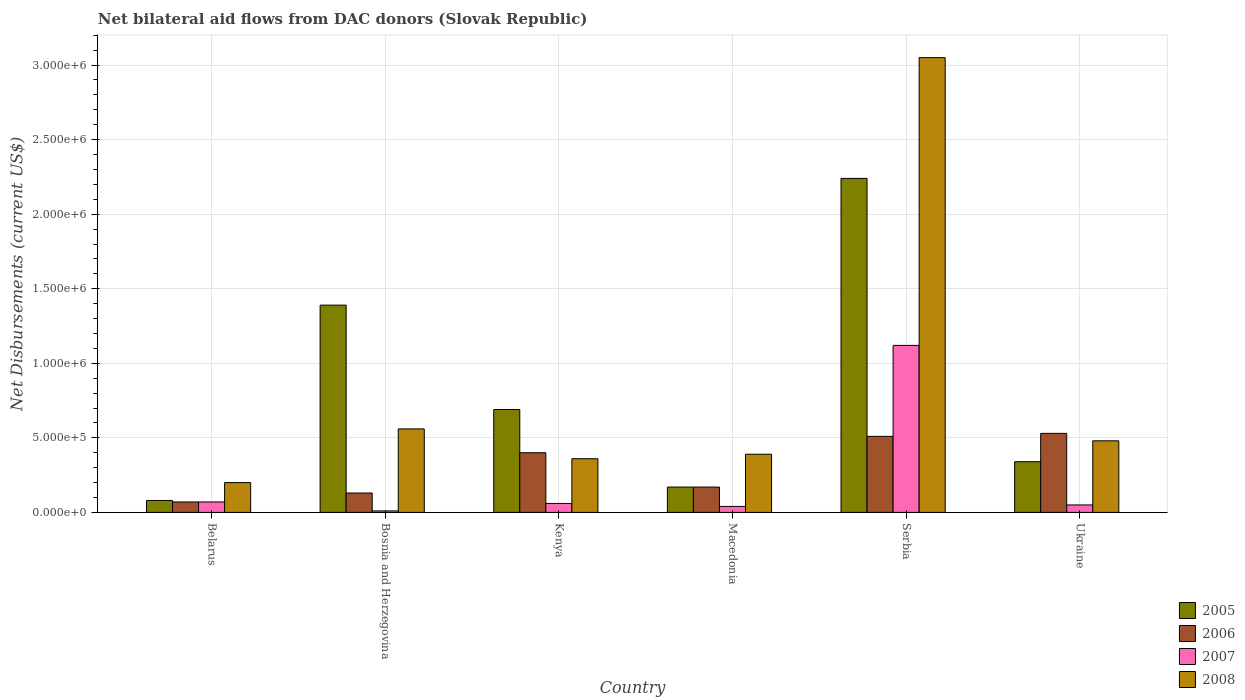How many groups of bars are there?
Make the answer very short. 6. Are the number of bars per tick equal to the number of legend labels?
Provide a succinct answer. Yes. Are the number of bars on each tick of the X-axis equal?
Offer a terse response. Yes. How many bars are there on the 1st tick from the right?
Offer a terse response. 4. What is the label of the 3rd group of bars from the left?
Your answer should be very brief. Kenya. Across all countries, what is the maximum net bilateral aid flows in 2008?
Keep it short and to the point. 3.05e+06. In which country was the net bilateral aid flows in 2006 maximum?
Keep it short and to the point. Ukraine. In which country was the net bilateral aid flows in 2006 minimum?
Make the answer very short. Belarus. What is the total net bilateral aid flows in 2007 in the graph?
Provide a short and direct response. 1.35e+06. What is the difference between the net bilateral aid flows in 2008 in Serbia and that in Ukraine?
Keep it short and to the point. 2.57e+06. What is the difference between the net bilateral aid flows in 2007 in Kenya and the net bilateral aid flows in 2008 in Bosnia and Herzegovina?
Make the answer very short. -5.00e+05. What is the average net bilateral aid flows in 2005 per country?
Keep it short and to the point. 8.18e+05. What is the difference between the net bilateral aid flows of/in 2006 and net bilateral aid flows of/in 2005 in Serbia?
Your answer should be very brief. -1.73e+06. In how many countries, is the net bilateral aid flows in 2006 greater than 300000 US$?
Your answer should be compact. 3. What is the ratio of the net bilateral aid flows in 2006 in Belarus to that in Bosnia and Herzegovina?
Your answer should be very brief. 0.54. Is the difference between the net bilateral aid flows in 2006 in Belarus and Macedonia greater than the difference between the net bilateral aid flows in 2005 in Belarus and Macedonia?
Provide a succinct answer. No. What is the difference between the highest and the second highest net bilateral aid flows in 2007?
Provide a short and direct response. 1.05e+06. What is the difference between the highest and the lowest net bilateral aid flows in 2006?
Give a very brief answer. 4.60e+05. Is the sum of the net bilateral aid flows in 2007 in Macedonia and Ukraine greater than the maximum net bilateral aid flows in 2008 across all countries?
Ensure brevity in your answer.  No. Is it the case that in every country, the sum of the net bilateral aid flows in 2006 and net bilateral aid flows in 2008 is greater than the sum of net bilateral aid flows in 2005 and net bilateral aid flows in 2007?
Give a very brief answer. Yes. How many countries are there in the graph?
Give a very brief answer. 6. What is the difference between two consecutive major ticks on the Y-axis?
Provide a short and direct response. 5.00e+05. Are the values on the major ticks of Y-axis written in scientific E-notation?
Give a very brief answer. Yes. Does the graph contain any zero values?
Give a very brief answer. No. Does the graph contain grids?
Ensure brevity in your answer.  Yes. Where does the legend appear in the graph?
Make the answer very short. Bottom right. How many legend labels are there?
Offer a terse response. 4. What is the title of the graph?
Keep it short and to the point. Net bilateral aid flows from DAC donors (Slovak Republic). Does "1979" appear as one of the legend labels in the graph?
Provide a succinct answer. No. What is the label or title of the X-axis?
Your response must be concise. Country. What is the label or title of the Y-axis?
Offer a very short reply. Net Disbursements (current US$). What is the Net Disbursements (current US$) in 2005 in Belarus?
Provide a short and direct response. 8.00e+04. What is the Net Disbursements (current US$) of 2006 in Belarus?
Your answer should be very brief. 7.00e+04. What is the Net Disbursements (current US$) of 2007 in Belarus?
Offer a terse response. 7.00e+04. What is the Net Disbursements (current US$) in 2005 in Bosnia and Herzegovina?
Make the answer very short. 1.39e+06. What is the Net Disbursements (current US$) of 2006 in Bosnia and Herzegovina?
Offer a terse response. 1.30e+05. What is the Net Disbursements (current US$) of 2008 in Bosnia and Herzegovina?
Provide a succinct answer. 5.60e+05. What is the Net Disbursements (current US$) of 2005 in Kenya?
Your answer should be very brief. 6.90e+05. What is the Net Disbursements (current US$) of 2007 in Kenya?
Offer a terse response. 6.00e+04. What is the Net Disbursements (current US$) in 2008 in Kenya?
Keep it short and to the point. 3.60e+05. What is the Net Disbursements (current US$) of 2005 in Macedonia?
Offer a terse response. 1.70e+05. What is the Net Disbursements (current US$) of 2007 in Macedonia?
Your answer should be compact. 4.00e+04. What is the Net Disbursements (current US$) in 2008 in Macedonia?
Give a very brief answer. 3.90e+05. What is the Net Disbursements (current US$) in 2005 in Serbia?
Ensure brevity in your answer.  2.24e+06. What is the Net Disbursements (current US$) of 2006 in Serbia?
Your response must be concise. 5.10e+05. What is the Net Disbursements (current US$) of 2007 in Serbia?
Your answer should be very brief. 1.12e+06. What is the Net Disbursements (current US$) in 2008 in Serbia?
Your answer should be very brief. 3.05e+06. What is the Net Disbursements (current US$) of 2005 in Ukraine?
Keep it short and to the point. 3.40e+05. What is the Net Disbursements (current US$) of 2006 in Ukraine?
Offer a very short reply. 5.30e+05. What is the Net Disbursements (current US$) in 2008 in Ukraine?
Make the answer very short. 4.80e+05. Across all countries, what is the maximum Net Disbursements (current US$) of 2005?
Keep it short and to the point. 2.24e+06. Across all countries, what is the maximum Net Disbursements (current US$) in 2006?
Offer a very short reply. 5.30e+05. Across all countries, what is the maximum Net Disbursements (current US$) in 2007?
Provide a short and direct response. 1.12e+06. Across all countries, what is the maximum Net Disbursements (current US$) of 2008?
Give a very brief answer. 3.05e+06. Across all countries, what is the minimum Net Disbursements (current US$) in 2007?
Give a very brief answer. 10000. Across all countries, what is the minimum Net Disbursements (current US$) in 2008?
Give a very brief answer. 2.00e+05. What is the total Net Disbursements (current US$) of 2005 in the graph?
Your response must be concise. 4.91e+06. What is the total Net Disbursements (current US$) in 2006 in the graph?
Offer a very short reply. 1.81e+06. What is the total Net Disbursements (current US$) of 2007 in the graph?
Make the answer very short. 1.35e+06. What is the total Net Disbursements (current US$) in 2008 in the graph?
Offer a very short reply. 5.04e+06. What is the difference between the Net Disbursements (current US$) of 2005 in Belarus and that in Bosnia and Herzegovina?
Give a very brief answer. -1.31e+06. What is the difference between the Net Disbursements (current US$) in 2006 in Belarus and that in Bosnia and Herzegovina?
Your answer should be compact. -6.00e+04. What is the difference between the Net Disbursements (current US$) in 2008 in Belarus and that in Bosnia and Herzegovina?
Make the answer very short. -3.60e+05. What is the difference between the Net Disbursements (current US$) of 2005 in Belarus and that in Kenya?
Ensure brevity in your answer.  -6.10e+05. What is the difference between the Net Disbursements (current US$) in 2006 in Belarus and that in Kenya?
Offer a very short reply. -3.30e+05. What is the difference between the Net Disbursements (current US$) in 2005 in Belarus and that in Macedonia?
Provide a short and direct response. -9.00e+04. What is the difference between the Net Disbursements (current US$) in 2008 in Belarus and that in Macedonia?
Your answer should be very brief. -1.90e+05. What is the difference between the Net Disbursements (current US$) in 2005 in Belarus and that in Serbia?
Offer a very short reply. -2.16e+06. What is the difference between the Net Disbursements (current US$) of 2006 in Belarus and that in Serbia?
Give a very brief answer. -4.40e+05. What is the difference between the Net Disbursements (current US$) of 2007 in Belarus and that in Serbia?
Your response must be concise. -1.05e+06. What is the difference between the Net Disbursements (current US$) of 2008 in Belarus and that in Serbia?
Provide a short and direct response. -2.85e+06. What is the difference between the Net Disbursements (current US$) in 2006 in Belarus and that in Ukraine?
Ensure brevity in your answer.  -4.60e+05. What is the difference between the Net Disbursements (current US$) of 2007 in Belarus and that in Ukraine?
Provide a succinct answer. 2.00e+04. What is the difference between the Net Disbursements (current US$) in 2008 in Belarus and that in Ukraine?
Provide a succinct answer. -2.80e+05. What is the difference between the Net Disbursements (current US$) of 2006 in Bosnia and Herzegovina and that in Kenya?
Offer a terse response. -2.70e+05. What is the difference between the Net Disbursements (current US$) of 2008 in Bosnia and Herzegovina and that in Kenya?
Your answer should be very brief. 2.00e+05. What is the difference between the Net Disbursements (current US$) in 2005 in Bosnia and Herzegovina and that in Macedonia?
Give a very brief answer. 1.22e+06. What is the difference between the Net Disbursements (current US$) of 2006 in Bosnia and Herzegovina and that in Macedonia?
Provide a succinct answer. -4.00e+04. What is the difference between the Net Disbursements (current US$) in 2008 in Bosnia and Herzegovina and that in Macedonia?
Keep it short and to the point. 1.70e+05. What is the difference between the Net Disbursements (current US$) in 2005 in Bosnia and Herzegovina and that in Serbia?
Your answer should be very brief. -8.50e+05. What is the difference between the Net Disbursements (current US$) in 2006 in Bosnia and Herzegovina and that in Serbia?
Offer a terse response. -3.80e+05. What is the difference between the Net Disbursements (current US$) in 2007 in Bosnia and Herzegovina and that in Serbia?
Offer a terse response. -1.11e+06. What is the difference between the Net Disbursements (current US$) of 2008 in Bosnia and Herzegovina and that in Serbia?
Your answer should be compact. -2.49e+06. What is the difference between the Net Disbursements (current US$) in 2005 in Bosnia and Herzegovina and that in Ukraine?
Your answer should be very brief. 1.05e+06. What is the difference between the Net Disbursements (current US$) of 2006 in Bosnia and Herzegovina and that in Ukraine?
Your response must be concise. -4.00e+05. What is the difference between the Net Disbursements (current US$) of 2008 in Bosnia and Herzegovina and that in Ukraine?
Your response must be concise. 8.00e+04. What is the difference between the Net Disbursements (current US$) in 2005 in Kenya and that in Macedonia?
Your response must be concise. 5.20e+05. What is the difference between the Net Disbursements (current US$) in 2007 in Kenya and that in Macedonia?
Ensure brevity in your answer.  2.00e+04. What is the difference between the Net Disbursements (current US$) of 2005 in Kenya and that in Serbia?
Make the answer very short. -1.55e+06. What is the difference between the Net Disbursements (current US$) in 2006 in Kenya and that in Serbia?
Your response must be concise. -1.10e+05. What is the difference between the Net Disbursements (current US$) in 2007 in Kenya and that in Serbia?
Keep it short and to the point. -1.06e+06. What is the difference between the Net Disbursements (current US$) of 2008 in Kenya and that in Serbia?
Keep it short and to the point. -2.69e+06. What is the difference between the Net Disbursements (current US$) of 2006 in Kenya and that in Ukraine?
Offer a terse response. -1.30e+05. What is the difference between the Net Disbursements (current US$) of 2007 in Kenya and that in Ukraine?
Offer a terse response. 10000. What is the difference between the Net Disbursements (current US$) in 2008 in Kenya and that in Ukraine?
Ensure brevity in your answer.  -1.20e+05. What is the difference between the Net Disbursements (current US$) of 2005 in Macedonia and that in Serbia?
Offer a very short reply. -2.07e+06. What is the difference between the Net Disbursements (current US$) of 2007 in Macedonia and that in Serbia?
Make the answer very short. -1.08e+06. What is the difference between the Net Disbursements (current US$) in 2008 in Macedonia and that in Serbia?
Provide a succinct answer. -2.66e+06. What is the difference between the Net Disbursements (current US$) of 2005 in Macedonia and that in Ukraine?
Ensure brevity in your answer.  -1.70e+05. What is the difference between the Net Disbursements (current US$) of 2006 in Macedonia and that in Ukraine?
Offer a very short reply. -3.60e+05. What is the difference between the Net Disbursements (current US$) in 2007 in Macedonia and that in Ukraine?
Offer a very short reply. -10000. What is the difference between the Net Disbursements (current US$) of 2005 in Serbia and that in Ukraine?
Your response must be concise. 1.90e+06. What is the difference between the Net Disbursements (current US$) in 2006 in Serbia and that in Ukraine?
Your answer should be compact. -2.00e+04. What is the difference between the Net Disbursements (current US$) in 2007 in Serbia and that in Ukraine?
Your response must be concise. 1.07e+06. What is the difference between the Net Disbursements (current US$) in 2008 in Serbia and that in Ukraine?
Make the answer very short. 2.57e+06. What is the difference between the Net Disbursements (current US$) in 2005 in Belarus and the Net Disbursements (current US$) in 2006 in Bosnia and Herzegovina?
Your answer should be very brief. -5.00e+04. What is the difference between the Net Disbursements (current US$) in 2005 in Belarus and the Net Disbursements (current US$) in 2007 in Bosnia and Herzegovina?
Your response must be concise. 7.00e+04. What is the difference between the Net Disbursements (current US$) of 2005 in Belarus and the Net Disbursements (current US$) of 2008 in Bosnia and Herzegovina?
Ensure brevity in your answer.  -4.80e+05. What is the difference between the Net Disbursements (current US$) in 2006 in Belarus and the Net Disbursements (current US$) in 2007 in Bosnia and Herzegovina?
Keep it short and to the point. 6.00e+04. What is the difference between the Net Disbursements (current US$) of 2006 in Belarus and the Net Disbursements (current US$) of 2008 in Bosnia and Herzegovina?
Your answer should be very brief. -4.90e+05. What is the difference between the Net Disbursements (current US$) of 2007 in Belarus and the Net Disbursements (current US$) of 2008 in Bosnia and Herzegovina?
Provide a succinct answer. -4.90e+05. What is the difference between the Net Disbursements (current US$) of 2005 in Belarus and the Net Disbursements (current US$) of 2006 in Kenya?
Give a very brief answer. -3.20e+05. What is the difference between the Net Disbursements (current US$) of 2005 in Belarus and the Net Disbursements (current US$) of 2008 in Kenya?
Ensure brevity in your answer.  -2.80e+05. What is the difference between the Net Disbursements (current US$) of 2006 in Belarus and the Net Disbursements (current US$) of 2008 in Kenya?
Provide a succinct answer. -2.90e+05. What is the difference between the Net Disbursements (current US$) in 2005 in Belarus and the Net Disbursements (current US$) in 2006 in Macedonia?
Keep it short and to the point. -9.00e+04. What is the difference between the Net Disbursements (current US$) in 2005 in Belarus and the Net Disbursements (current US$) in 2007 in Macedonia?
Make the answer very short. 4.00e+04. What is the difference between the Net Disbursements (current US$) in 2005 in Belarus and the Net Disbursements (current US$) in 2008 in Macedonia?
Your answer should be very brief. -3.10e+05. What is the difference between the Net Disbursements (current US$) of 2006 in Belarus and the Net Disbursements (current US$) of 2008 in Macedonia?
Keep it short and to the point. -3.20e+05. What is the difference between the Net Disbursements (current US$) of 2007 in Belarus and the Net Disbursements (current US$) of 2008 in Macedonia?
Provide a succinct answer. -3.20e+05. What is the difference between the Net Disbursements (current US$) of 2005 in Belarus and the Net Disbursements (current US$) of 2006 in Serbia?
Provide a short and direct response. -4.30e+05. What is the difference between the Net Disbursements (current US$) in 2005 in Belarus and the Net Disbursements (current US$) in 2007 in Serbia?
Provide a short and direct response. -1.04e+06. What is the difference between the Net Disbursements (current US$) in 2005 in Belarus and the Net Disbursements (current US$) in 2008 in Serbia?
Keep it short and to the point. -2.97e+06. What is the difference between the Net Disbursements (current US$) in 2006 in Belarus and the Net Disbursements (current US$) in 2007 in Serbia?
Your answer should be compact. -1.05e+06. What is the difference between the Net Disbursements (current US$) of 2006 in Belarus and the Net Disbursements (current US$) of 2008 in Serbia?
Give a very brief answer. -2.98e+06. What is the difference between the Net Disbursements (current US$) in 2007 in Belarus and the Net Disbursements (current US$) in 2008 in Serbia?
Your answer should be very brief. -2.98e+06. What is the difference between the Net Disbursements (current US$) of 2005 in Belarus and the Net Disbursements (current US$) of 2006 in Ukraine?
Keep it short and to the point. -4.50e+05. What is the difference between the Net Disbursements (current US$) of 2005 in Belarus and the Net Disbursements (current US$) of 2007 in Ukraine?
Ensure brevity in your answer.  3.00e+04. What is the difference between the Net Disbursements (current US$) of 2005 in Belarus and the Net Disbursements (current US$) of 2008 in Ukraine?
Offer a very short reply. -4.00e+05. What is the difference between the Net Disbursements (current US$) of 2006 in Belarus and the Net Disbursements (current US$) of 2007 in Ukraine?
Offer a terse response. 2.00e+04. What is the difference between the Net Disbursements (current US$) in 2006 in Belarus and the Net Disbursements (current US$) in 2008 in Ukraine?
Your response must be concise. -4.10e+05. What is the difference between the Net Disbursements (current US$) in 2007 in Belarus and the Net Disbursements (current US$) in 2008 in Ukraine?
Your response must be concise. -4.10e+05. What is the difference between the Net Disbursements (current US$) in 2005 in Bosnia and Herzegovina and the Net Disbursements (current US$) in 2006 in Kenya?
Your response must be concise. 9.90e+05. What is the difference between the Net Disbursements (current US$) in 2005 in Bosnia and Herzegovina and the Net Disbursements (current US$) in 2007 in Kenya?
Your answer should be very brief. 1.33e+06. What is the difference between the Net Disbursements (current US$) of 2005 in Bosnia and Herzegovina and the Net Disbursements (current US$) of 2008 in Kenya?
Your response must be concise. 1.03e+06. What is the difference between the Net Disbursements (current US$) of 2006 in Bosnia and Herzegovina and the Net Disbursements (current US$) of 2008 in Kenya?
Your response must be concise. -2.30e+05. What is the difference between the Net Disbursements (current US$) in 2007 in Bosnia and Herzegovina and the Net Disbursements (current US$) in 2008 in Kenya?
Give a very brief answer. -3.50e+05. What is the difference between the Net Disbursements (current US$) in 2005 in Bosnia and Herzegovina and the Net Disbursements (current US$) in 2006 in Macedonia?
Your answer should be compact. 1.22e+06. What is the difference between the Net Disbursements (current US$) in 2005 in Bosnia and Herzegovina and the Net Disbursements (current US$) in 2007 in Macedonia?
Give a very brief answer. 1.35e+06. What is the difference between the Net Disbursements (current US$) in 2005 in Bosnia and Herzegovina and the Net Disbursements (current US$) in 2008 in Macedonia?
Your answer should be compact. 1.00e+06. What is the difference between the Net Disbursements (current US$) of 2006 in Bosnia and Herzegovina and the Net Disbursements (current US$) of 2007 in Macedonia?
Offer a terse response. 9.00e+04. What is the difference between the Net Disbursements (current US$) in 2007 in Bosnia and Herzegovina and the Net Disbursements (current US$) in 2008 in Macedonia?
Offer a terse response. -3.80e+05. What is the difference between the Net Disbursements (current US$) of 2005 in Bosnia and Herzegovina and the Net Disbursements (current US$) of 2006 in Serbia?
Your answer should be very brief. 8.80e+05. What is the difference between the Net Disbursements (current US$) in 2005 in Bosnia and Herzegovina and the Net Disbursements (current US$) in 2007 in Serbia?
Provide a short and direct response. 2.70e+05. What is the difference between the Net Disbursements (current US$) in 2005 in Bosnia and Herzegovina and the Net Disbursements (current US$) in 2008 in Serbia?
Your response must be concise. -1.66e+06. What is the difference between the Net Disbursements (current US$) in 2006 in Bosnia and Herzegovina and the Net Disbursements (current US$) in 2007 in Serbia?
Keep it short and to the point. -9.90e+05. What is the difference between the Net Disbursements (current US$) in 2006 in Bosnia and Herzegovina and the Net Disbursements (current US$) in 2008 in Serbia?
Offer a terse response. -2.92e+06. What is the difference between the Net Disbursements (current US$) of 2007 in Bosnia and Herzegovina and the Net Disbursements (current US$) of 2008 in Serbia?
Provide a succinct answer. -3.04e+06. What is the difference between the Net Disbursements (current US$) in 2005 in Bosnia and Herzegovina and the Net Disbursements (current US$) in 2006 in Ukraine?
Provide a short and direct response. 8.60e+05. What is the difference between the Net Disbursements (current US$) of 2005 in Bosnia and Herzegovina and the Net Disbursements (current US$) of 2007 in Ukraine?
Provide a short and direct response. 1.34e+06. What is the difference between the Net Disbursements (current US$) of 2005 in Bosnia and Herzegovina and the Net Disbursements (current US$) of 2008 in Ukraine?
Your answer should be compact. 9.10e+05. What is the difference between the Net Disbursements (current US$) in 2006 in Bosnia and Herzegovina and the Net Disbursements (current US$) in 2007 in Ukraine?
Your answer should be very brief. 8.00e+04. What is the difference between the Net Disbursements (current US$) of 2006 in Bosnia and Herzegovina and the Net Disbursements (current US$) of 2008 in Ukraine?
Your answer should be very brief. -3.50e+05. What is the difference between the Net Disbursements (current US$) in 2007 in Bosnia and Herzegovina and the Net Disbursements (current US$) in 2008 in Ukraine?
Ensure brevity in your answer.  -4.70e+05. What is the difference between the Net Disbursements (current US$) in 2005 in Kenya and the Net Disbursements (current US$) in 2006 in Macedonia?
Ensure brevity in your answer.  5.20e+05. What is the difference between the Net Disbursements (current US$) in 2005 in Kenya and the Net Disbursements (current US$) in 2007 in Macedonia?
Offer a terse response. 6.50e+05. What is the difference between the Net Disbursements (current US$) in 2005 in Kenya and the Net Disbursements (current US$) in 2008 in Macedonia?
Give a very brief answer. 3.00e+05. What is the difference between the Net Disbursements (current US$) in 2006 in Kenya and the Net Disbursements (current US$) in 2008 in Macedonia?
Ensure brevity in your answer.  10000. What is the difference between the Net Disbursements (current US$) in 2007 in Kenya and the Net Disbursements (current US$) in 2008 in Macedonia?
Your answer should be very brief. -3.30e+05. What is the difference between the Net Disbursements (current US$) of 2005 in Kenya and the Net Disbursements (current US$) of 2007 in Serbia?
Your answer should be very brief. -4.30e+05. What is the difference between the Net Disbursements (current US$) of 2005 in Kenya and the Net Disbursements (current US$) of 2008 in Serbia?
Provide a short and direct response. -2.36e+06. What is the difference between the Net Disbursements (current US$) in 2006 in Kenya and the Net Disbursements (current US$) in 2007 in Serbia?
Provide a succinct answer. -7.20e+05. What is the difference between the Net Disbursements (current US$) of 2006 in Kenya and the Net Disbursements (current US$) of 2008 in Serbia?
Make the answer very short. -2.65e+06. What is the difference between the Net Disbursements (current US$) in 2007 in Kenya and the Net Disbursements (current US$) in 2008 in Serbia?
Your answer should be compact. -2.99e+06. What is the difference between the Net Disbursements (current US$) in 2005 in Kenya and the Net Disbursements (current US$) in 2007 in Ukraine?
Offer a terse response. 6.40e+05. What is the difference between the Net Disbursements (current US$) of 2007 in Kenya and the Net Disbursements (current US$) of 2008 in Ukraine?
Your response must be concise. -4.20e+05. What is the difference between the Net Disbursements (current US$) in 2005 in Macedonia and the Net Disbursements (current US$) in 2007 in Serbia?
Offer a terse response. -9.50e+05. What is the difference between the Net Disbursements (current US$) in 2005 in Macedonia and the Net Disbursements (current US$) in 2008 in Serbia?
Make the answer very short. -2.88e+06. What is the difference between the Net Disbursements (current US$) of 2006 in Macedonia and the Net Disbursements (current US$) of 2007 in Serbia?
Your answer should be very brief. -9.50e+05. What is the difference between the Net Disbursements (current US$) of 2006 in Macedonia and the Net Disbursements (current US$) of 2008 in Serbia?
Keep it short and to the point. -2.88e+06. What is the difference between the Net Disbursements (current US$) of 2007 in Macedonia and the Net Disbursements (current US$) of 2008 in Serbia?
Keep it short and to the point. -3.01e+06. What is the difference between the Net Disbursements (current US$) in 2005 in Macedonia and the Net Disbursements (current US$) in 2006 in Ukraine?
Provide a succinct answer. -3.60e+05. What is the difference between the Net Disbursements (current US$) in 2005 in Macedonia and the Net Disbursements (current US$) in 2008 in Ukraine?
Your response must be concise. -3.10e+05. What is the difference between the Net Disbursements (current US$) of 2006 in Macedonia and the Net Disbursements (current US$) of 2007 in Ukraine?
Your answer should be very brief. 1.20e+05. What is the difference between the Net Disbursements (current US$) of 2006 in Macedonia and the Net Disbursements (current US$) of 2008 in Ukraine?
Keep it short and to the point. -3.10e+05. What is the difference between the Net Disbursements (current US$) of 2007 in Macedonia and the Net Disbursements (current US$) of 2008 in Ukraine?
Offer a terse response. -4.40e+05. What is the difference between the Net Disbursements (current US$) in 2005 in Serbia and the Net Disbursements (current US$) in 2006 in Ukraine?
Make the answer very short. 1.71e+06. What is the difference between the Net Disbursements (current US$) of 2005 in Serbia and the Net Disbursements (current US$) of 2007 in Ukraine?
Give a very brief answer. 2.19e+06. What is the difference between the Net Disbursements (current US$) of 2005 in Serbia and the Net Disbursements (current US$) of 2008 in Ukraine?
Keep it short and to the point. 1.76e+06. What is the difference between the Net Disbursements (current US$) of 2006 in Serbia and the Net Disbursements (current US$) of 2007 in Ukraine?
Your answer should be very brief. 4.60e+05. What is the difference between the Net Disbursements (current US$) of 2006 in Serbia and the Net Disbursements (current US$) of 2008 in Ukraine?
Offer a very short reply. 3.00e+04. What is the difference between the Net Disbursements (current US$) of 2007 in Serbia and the Net Disbursements (current US$) of 2008 in Ukraine?
Ensure brevity in your answer.  6.40e+05. What is the average Net Disbursements (current US$) of 2005 per country?
Keep it short and to the point. 8.18e+05. What is the average Net Disbursements (current US$) of 2006 per country?
Give a very brief answer. 3.02e+05. What is the average Net Disbursements (current US$) of 2007 per country?
Give a very brief answer. 2.25e+05. What is the average Net Disbursements (current US$) of 2008 per country?
Offer a very short reply. 8.40e+05. What is the difference between the Net Disbursements (current US$) of 2005 and Net Disbursements (current US$) of 2006 in Belarus?
Your response must be concise. 10000. What is the difference between the Net Disbursements (current US$) in 2005 and Net Disbursements (current US$) in 2007 in Belarus?
Offer a terse response. 10000. What is the difference between the Net Disbursements (current US$) in 2006 and Net Disbursements (current US$) in 2007 in Belarus?
Keep it short and to the point. 0. What is the difference between the Net Disbursements (current US$) of 2006 and Net Disbursements (current US$) of 2008 in Belarus?
Give a very brief answer. -1.30e+05. What is the difference between the Net Disbursements (current US$) of 2007 and Net Disbursements (current US$) of 2008 in Belarus?
Keep it short and to the point. -1.30e+05. What is the difference between the Net Disbursements (current US$) in 2005 and Net Disbursements (current US$) in 2006 in Bosnia and Herzegovina?
Offer a very short reply. 1.26e+06. What is the difference between the Net Disbursements (current US$) of 2005 and Net Disbursements (current US$) of 2007 in Bosnia and Herzegovina?
Offer a very short reply. 1.38e+06. What is the difference between the Net Disbursements (current US$) in 2005 and Net Disbursements (current US$) in 2008 in Bosnia and Herzegovina?
Ensure brevity in your answer.  8.30e+05. What is the difference between the Net Disbursements (current US$) in 2006 and Net Disbursements (current US$) in 2007 in Bosnia and Herzegovina?
Your answer should be very brief. 1.20e+05. What is the difference between the Net Disbursements (current US$) in 2006 and Net Disbursements (current US$) in 2008 in Bosnia and Herzegovina?
Your answer should be very brief. -4.30e+05. What is the difference between the Net Disbursements (current US$) of 2007 and Net Disbursements (current US$) of 2008 in Bosnia and Herzegovina?
Give a very brief answer. -5.50e+05. What is the difference between the Net Disbursements (current US$) in 2005 and Net Disbursements (current US$) in 2006 in Kenya?
Your answer should be compact. 2.90e+05. What is the difference between the Net Disbursements (current US$) of 2005 and Net Disbursements (current US$) of 2007 in Kenya?
Provide a succinct answer. 6.30e+05. What is the difference between the Net Disbursements (current US$) in 2005 and Net Disbursements (current US$) in 2008 in Kenya?
Keep it short and to the point. 3.30e+05. What is the difference between the Net Disbursements (current US$) in 2006 and Net Disbursements (current US$) in 2007 in Kenya?
Provide a succinct answer. 3.40e+05. What is the difference between the Net Disbursements (current US$) of 2007 and Net Disbursements (current US$) of 2008 in Kenya?
Your response must be concise. -3.00e+05. What is the difference between the Net Disbursements (current US$) of 2005 and Net Disbursements (current US$) of 2007 in Macedonia?
Your response must be concise. 1.30e+05. What is the difference between the Net Disbursements (current US$) in 2005 and Net Disbursements (current US$) in 2008 in Macedonia?
Keep it short and to the point. -2.20e+05. What is the difference between the Net Disbursements (current US$) in 2006 and Net Disbursements (current US$) in 2008 in Macedonia?
Ensure brevity in your answer.  -2.20e+05. What is the difference between the Net Disbursements (current US$) of 2007 and Net Disbursements (current US$) of 2008 in Macedonia?
Your response must be concise. -3.50e+05. What is the difference between the Net Disbursements (current US$) of 2005 and Net Disbursements (current US$) of 2006 in Serbia?
Your answer should be very brief. 1.73e+06. What is the difference between the Net Disbursements (current US$) of 2005 and Net Disbursements (current US$) of 2007 in Serbia?
Provide a succinct answer. 1.12e+06. What is the difference between the Net Disbursements (current US$) in 2005 and Net Disbursements (current US$) in 2008 in Serbia?
Offer a very short reply. -8.10e+05. What is the difference between the Net Disbursements (current US$) of 2006 and Net Disbursements (current US$) of 2007 in Serbia?
Keep it short and to the point. -6.10e+05. What is the difference between the Net Disbursements (current US$) of 2006 and Net Disbursements (current US$) of 2008 in Serbia?
Your answer should be compact. -2.54e+06. What is the difference between the Net Disbursements (current US$) of 2007 and Net Disbursements (current US$) of 2008 in Serbia?
Keep it short and to the point. -1.93e+06. What is the difference between the Net Disbursements (current US$) of 2005 and Net Disbursements (current US$) of 2006 in Ukraine?
Keep it short and to the point. -1.90e+05. What is the difference between the Net Disbursements (current US$) of 2005 and Net Disbursements (current US$) of 2008 in Ukraine?
Ensure brevity in your answer.  -1.40e+05. What is the difference between the Net Disbursements (current US$) in 2007 and Net Disbursements (current US$) in 2008 in Ukraine?
Your response must be concise. -4.30e+05. What is the ratio of the Net Disbursements (current US$) of 2005 in Belarus to that in Bosnia and Herzegovina?
Provide a succinct answer. 0.06. What is the ratio of the Net Disbursements (current US$) of 2006 in Belarus to that in Bosnia and Herzegovina?
Keep it short and to the point. 0.54. What is the ratio of the Net Disbursements (current US$) of 2008 in Belarus to that in Bosnia and Herzegovina?
Your answer should be very brief. 0.36. What is the ratio of the Net Disbursements (current US$) of 2005 in Belarus to that in Kenya?
Ensure brevity in your answer.  0.12. What is the ratio of the Net Disbursements (current US$) in 2006 in Belarus to that in Kenya?
Ensure brevity in your answer.  0.17. What is the ratio of the Net Disbursements (current US$) in 2008 in Belarus to that in Kenya?
Provide a short and direct response. 0.56. What is the ratio of the Net Disbursements (current US$) of 2005 in Belarus to that in Macedonia?
Your answer should be very brief. 0.47. What is the ratio of the Net Disbursements (current US$) in 2006 in Belarus to that in Macedonia?
Provide a succinct answer. 0.41. What is the ratio of the Net Disbursements (current US$) of 2008 in Belarus to that in Macedonia?
Provide a short and direct response. 0.51. What is the ratio of the Net Disbursements (current US$) of 2005 in Belarus to that in Serbia?
Your response must be concise. 0.04. What is the ratio of the Net Disbursements (current US$) in 2006 in Belarus to that in Serbia?
Ensure brevity in your answer.  0.14. What is the ratio of the Net Disbursements (current US$) in 2007 in Belarus to that in Serbia?
Offer a terse response. 0.06. What is the ratio of the Net Disbursements (current US$) in 2008 in Belarus to that in Serbia?
Ensure brevity in your answer.  0.07. What is the ratio of the Net Disbursements (current US$) of 2005 in Belarus to that in Ukraine?
Keep it short and to the point. 0.24. What is the ratio of the Net Disbursements (current US$) of 2006 in Belarus to that in Ukraine?
Give a very brief answer. 0.13. What is the ratio of the Net Disbursements (current US$) of 2007 in Belarus to that in Ukraine?
Keep it short and to the point. 1.4. What is the ratio of the Net Disbursements (current US$) in 2008 in Belarus to that in Ukraine?
Provide a succinct answer. 0.42. What is the ratio of the Net Disbursements (current US$) in 2005 in Bosnia and Herzegovina to that in Kenya?
Offer a very short reply. 2.01. What is the ratio of the Net Disbursements (current US$) in 2006 in Bosnia and Herzegovina to that in Kenya?
Your response must be concise. 0.33. What is the ratio of the Net Disbursements (current US$) in 2007 in Bosnia and Herzegovina to that in Kenya?
Your answer should be very brief. 0.17. What is the ratio of the Net Disbursements (current US$) of 2008 in Bosnia and Herzegovina to that in Kenya?
Your response must be concise. 1.56. What is the ratio of the Net Disbursements (current US$) in 2005 in Bosnia and Herzegovina to that in Macedonia?
Provide a short and direct response. 8.18. What is the ratio of the Net Disbursements (current US$) in 2006 in Bosnia and Herzegovina to that in Macedonia?
Offer a terse response. 0.76. What is the ratio of the Net Disbursements (current US$) in 2007 in Bosnia and Herzegovina to that in Macedonia?
Your response must be concise. 0.25. What is the ratio of the Net Disbursements (current US$) of 2008 in Bosnia and Herzegovina to that in Macedonia?
Make the answer very short. 1.44. What is the ratio of the Net Disbursements (current US$) in 2005 in Bosnia and Herzegovina to that in Serbia?
Give a very brief answer. 0.62. What is the ratio of the Net Disbursements (current US$) of 2006 in Bosnia and Herzegovina to that in Serbia?
Your answer should be very brief. 0.25. What is the ratio of the Net Disbursements (current US$) of 2007 in Bosnia and Herzegovina to that in Serbia?
Provide a succinct answer. 0.01. What is the ratio of the Net Disbursements (current US$) of 2008 in Bosnia and Herzegovina to that in Serbia?
Give a very brief answer. 0.18. What is the ratio of the Net Disbursements (current US$) of 2005 in Bosnia and Herzegovina to that in Ukraine?
Your answer should be compact. 4.09. What is the ratio of the Net Disbursements (current US$) in 2006 in Bosnia and Herzegovina to that in Ukraine?
Keep it short and to the point. 0.25. What is the ratio of the Net Disbursements (current US$) in 2007 in Bosnia and Herzegovina to that in Ukraine?
Provide a short and direct response. 0.2. What is the ratio of the Net Disbursements (current US$) in 2005 in Kenya to that in Macedonia?
Ensure brevity in your answer.  4.06. What is the ratio of the Net Disbursements (current US$) of 2006 in Kenya to that in Macedonia?
Your answer should be compact. 2.35. What is the ratio of the Net Disbursements (current US$) of 2007 in Kenya to that in Macedonia?
Offer a terse response. 1.5. What is the ratio of the Net Disbursements (current US$) in 2008 in Kenya to that in Macedonia?
Offer a terse response. 0.92. What is the ratio of the Net Disbursements (current US$) of 2005 in Kenya to that in Serbia?
Offer a very short reply. 0.31. What is the ratio of the Net Disbursements (current US$) of 2006 in Kenya to that in Serbia?
Provide a short and direct response. 0.78. What is the ratio of the Net Disbursements (current US$) in 2007 in Kenya to that in Serbia?
Make the answer very short. 0.05. What is the ratio of the Net Disbursements (current US$) of 2008 in Kenya to that in Serbia?
Offer a terse response. 0.12. What is the ratio of the Net Disbursements (current US$) of 2005 in Kenya to that in Ukraine?
Your answer should be compact. 2.03. What is the ratio of the Net Disbursements (current US$) in 2006 in Kenya to that in Ukraine?
Provide a succinct answer. 0.75. What is the ratio of the Net Disbursements (current US$) of 2008 in Kenya to that in Ukraine?
Keep it short and to the point. 0.75. What is the ratio of the Net Disbursements (current US$) in 2005 in Macedonia to that in Serbia?
Provide a succinct answer. 0.08. What is the ratio of the Net Disbursements (current US$) in 2007 in Macedonia to that in Serbia?
Provide a succinct answer. 0.04. What is the ratio of the Net Disbursements (current US$) of 2008 in Macedonia to that in Serbia?
Offer a terse response. 0.13. What is the ratio of the Net Disbursements (current US$) in 2005 in Macedonia to that in Ukraine?
Give a very brief answer. 0.5. What is the ratio of the Net Disbursements (current US$) of 2006 in Macedonia to that in Ukraine?
Your answer should be compact. 0.32. What is the ratio of the Net Disbursements (current US$) in 2008 in Macedonia to that in Ukraine?
Your answer should be very brief. 0.81. What is the ratio of the Net Disbursements (current US$) in 2005 in Serbia to that in Ukraine?
Give a very brief answer. 6.59. What is the ratio of the Net Disbursements (current US$) of 2006 in Serbia to that in Ukraine?
Offer a terse response. 0.96. What is the ratio of the Net Disbursements (current US$) in 2007 in Serbia to that in Ukraine?
Your answer should be compact. 22.4. What is the ratio of the Net Disbursements (current US$) of 2008 in Serbia to that in Ukraine?
Make the answer very short. 6.35. What is the difference between the highest and the second highest Net Disbursements (current US$) in 2005?
Your answer should be compact. 8.50e+05. What is the difference between the highest and the second highest Net Disbursements (current US$) of 2006?
Ensure brevity in your answer.  2.00e+04. What is the difference between the highest and the second highest Net Disbursements (current US$) in 2007?
Your answer should be compact. 1.05e+06. What is the difference between the highest and the second highest Net Disbursements (current US$) in 2008?
Your response must be concise. 2.49e+06. What is the difference between the highest and the lowest Net Disbursements (current US$) in 2005?
Your answer should be very brief. 2.16e+06. What is the difference between the highest and the lowest Net Disbursements (current US$) in 2006?
Provide a succinct answer. 4.60e+05. What is the difference between the highest and the lowest Net Disbursements (current US$) in 2007?
Keep it short and to the point. 1.11e+06. What is the difference between the highest and the lowest Net Disbursements (current US$) of 2008?
Give a very brief answer. 2.85e+06. 